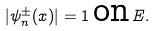Convert formula to latex. <formula><loc_0><loc_0><loc_500><loc_500>| \psi _ { n } ^ { \pm } ( x ) | = 1 \, \text {on} \, E .</formula> 